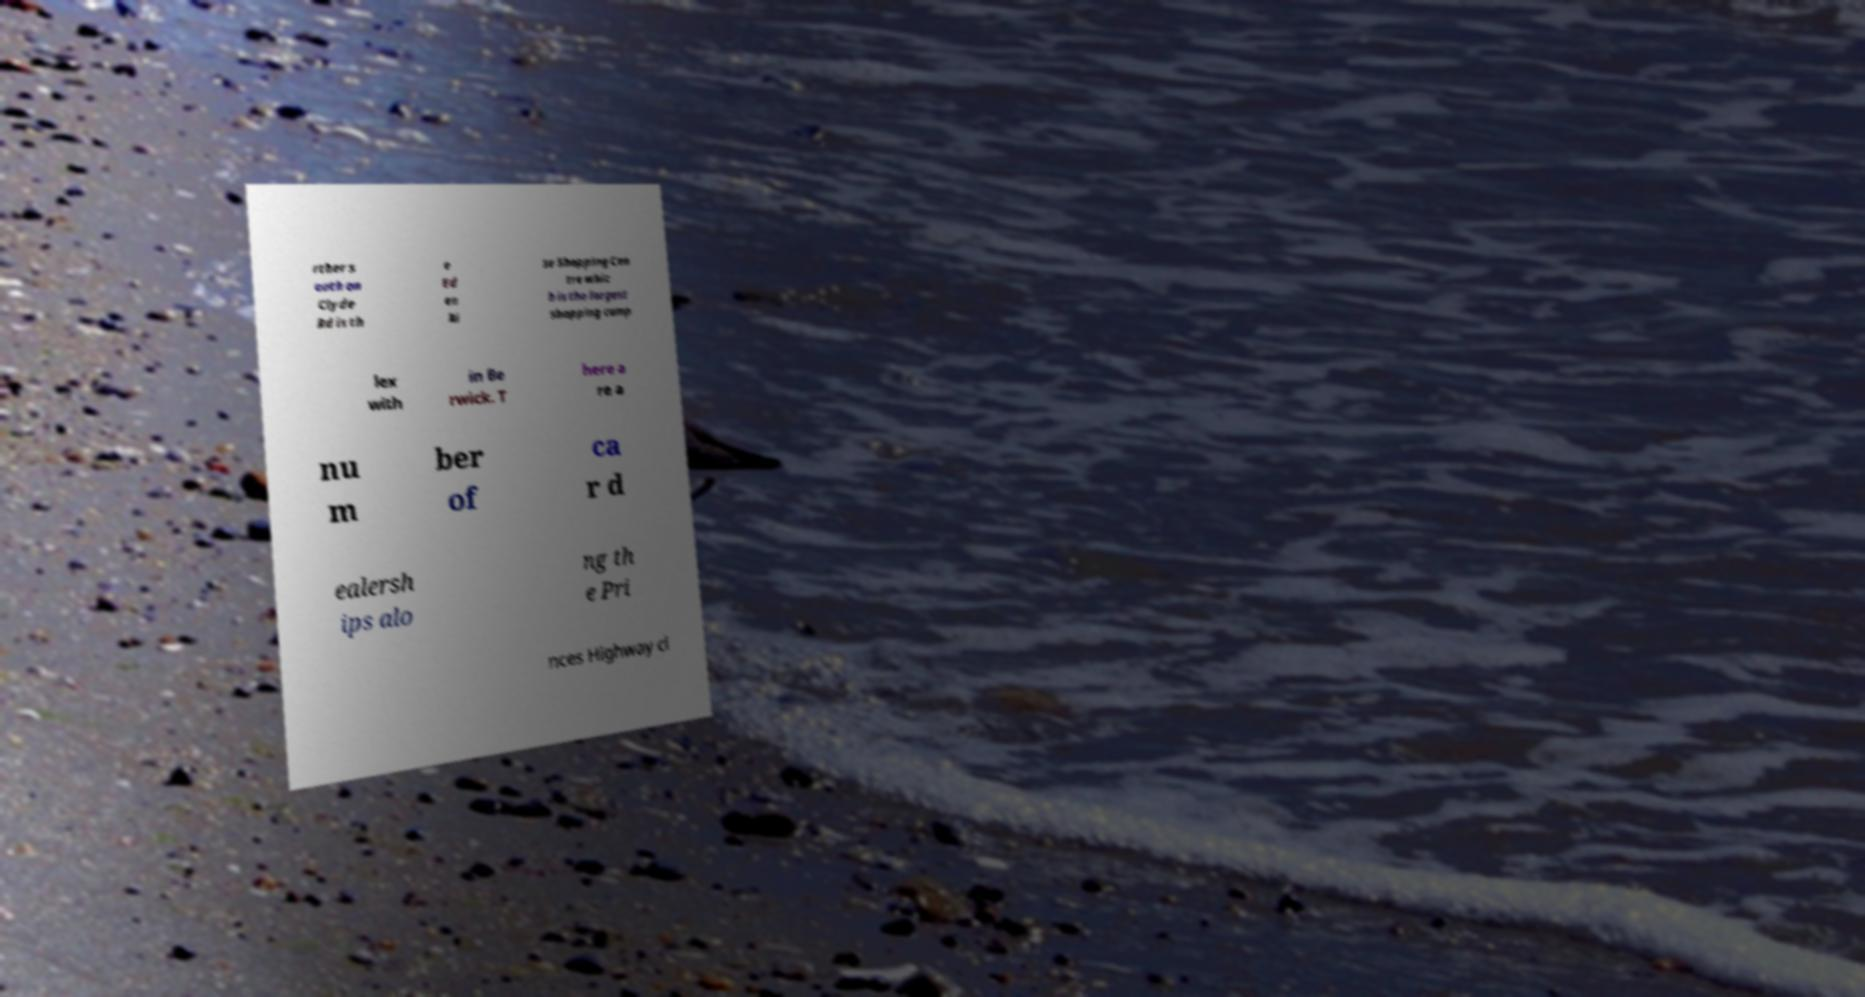There's text embedded in this image that I need extracted. Can you transcribe it verbatim? rther s outh on Clyde Rd is th e Ed en Ri se Shopping Cen tre whic h is the largest shopping comp lex with in Be rwick. T here a re a nu m ber of ca r d ealersh ips alo ng th e Pri nces Highway cl 